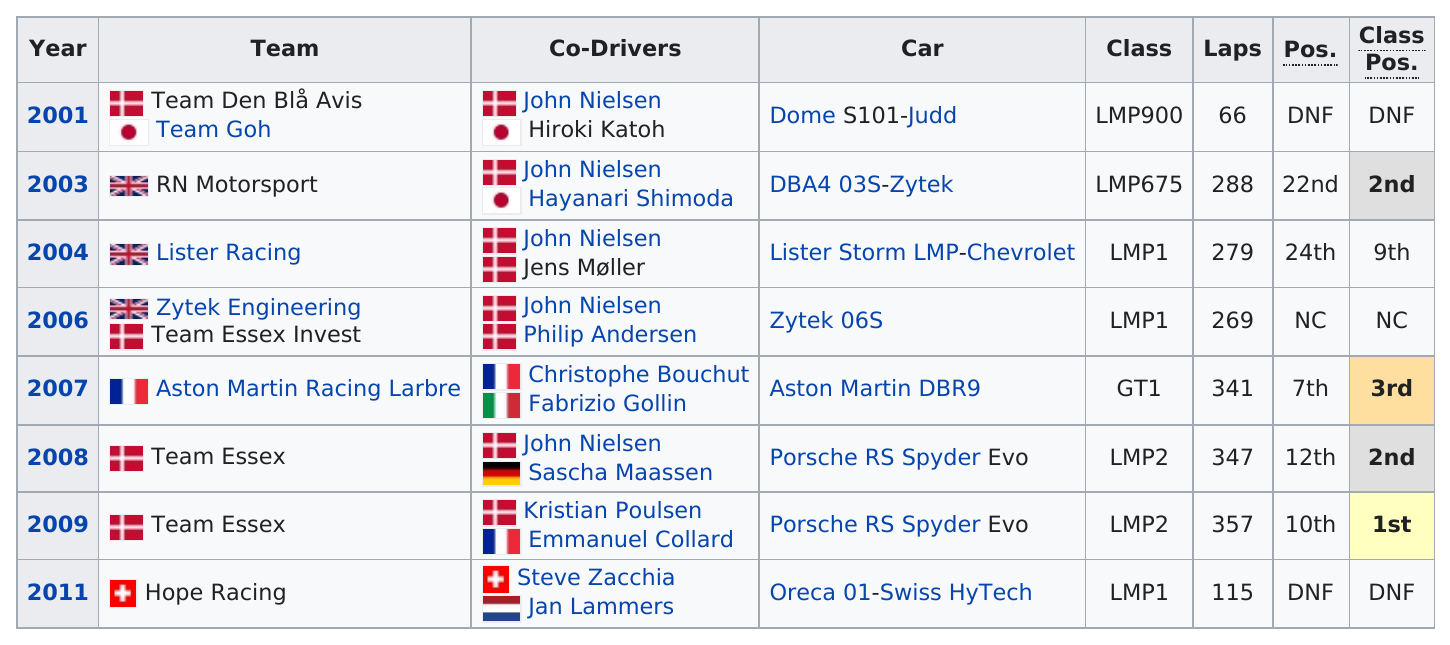Give some essential details in this illustration. The Porsche RS Spyder was the most commonly used model car. The Porsche RS Spyder was used in competition a total of two times. Hope Racing's team did not finish the race in 2011. The final position was above 20 a total of 2 times. John Nielsen was the co-driver for Team Lister in 2004, and his co-driver was Jens Møller. 